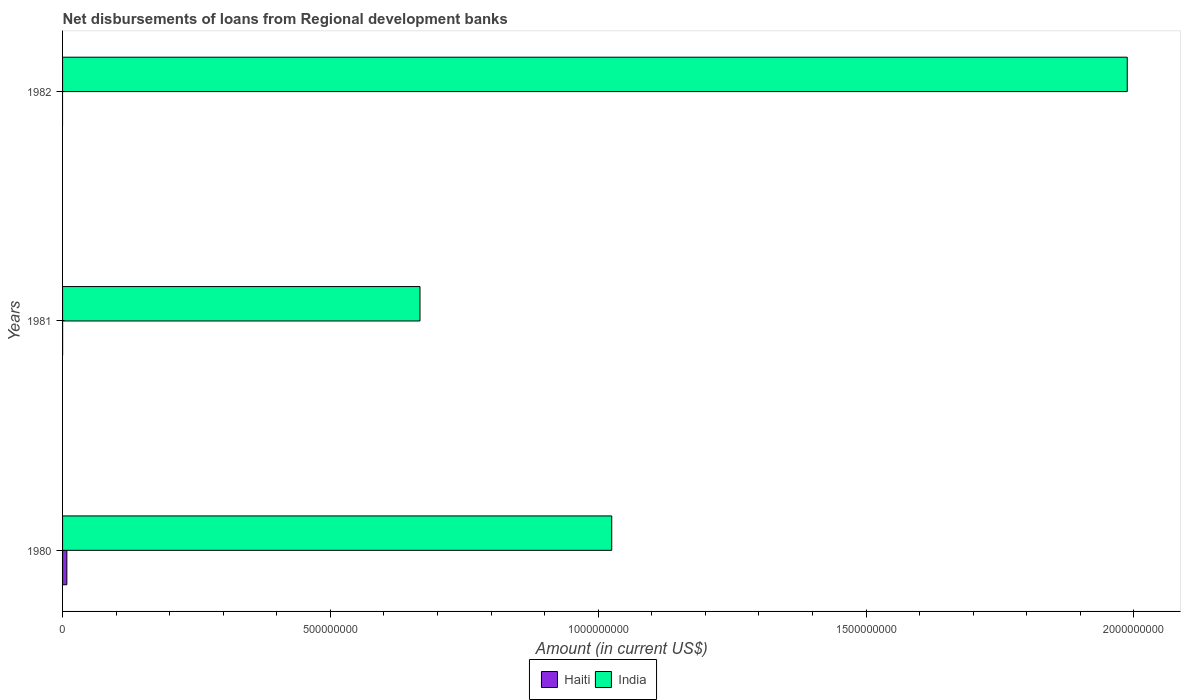How many bars are there on the 1st tick from the bottom?
Offer a terse response. 2. What is the label of the 3rd group of bars from the top?
Your answer should be very brief. 1980. What is the amount of disbursements of loans from regional development banks in Haiti in 1982?
Your answer should be very brief. 0. Across all years, what is the maximum amount of disbursements of loans from regional development banks in Haiti?
Your response must be concise. 7.99e+06. Across all years, what is the minimum amount of disbursements of loans from regional development banks in India?
Provide a succinct answer. 6.67e+08. What is the total amount of disbursements of loans from regional development banks in India in the graph?
Your response must be concise. 3.68e+09. What is the difference between the amount of disbursements of loans from regional development banks in India in 1981 and that in 1982?
Offer a terse response. -1.32e+09. What is the difference between the amount of disbursements of loans from regional development banks in Haiti in 1981 and the amount of disbursements of loans from regional development banks in India in 1982?
Provide a short and direct response. -1.99e+09. What is the average amount of disbursements of loans from regional development banks in Haiti per year?
Give a very brief answer. 2.69e+06. In the year 1980, what is the difference between the amount of disbursements of loans from regional development banks in India and amount of disbursements of loans from regional development banks in Haiti?
Ensure brevity in your answer.  1.02e+09. What is the ratio of the amount of disbursements of loans from regional development banks in India in 1981 to that in 1982?
Make the answer very short. 0.34. What is the difference between the highest and the lowest amount of disbursements of loans from regional development banks in Haiti?
Offer a very short reply. 7.99e+06. Is the sum of the amount of disbursements of loans from regional development banks in India in 1981 and 1982 greater than the maximum amount of disbursements of loans from regional development banks in Haiti across all years?
Make the answer very short. Yes. How many years are there in the graph?
Your answer should be very brief. 3. Does the graph contain any zero values?
Your answer should be very brief. Yes. How many legend labels are there?
Provide a succinct answer. 2. How are the legend labels stacked?
Give a very brief answer. Horizontal. What is the title of the graph?
Your answer should be very brief. Net disbursements of loans from Regional development banks. What is the label or title of the X-axis?
Ensure brevity in your answer.  Amount (in current US$). What is the label or title of the Y-axis?
Make the answer very short. Years. What is the Amount (in current US$) of Haiti in 1980?
Keep it short and to the point. 7.99e+06. What is the Amount (in current US$) in India in 1980?
Give a very brief answer. 1.03e+09. What is the Amount (in current US$) of Haiti in 1981?
Your answer should be compact. 8.70e+04. What is the Amount (in current US$) of India in 1981?
Give a very brief answer. 6.67e+08. What is the Amount (in current US$) of India in 1982?
Provide a succinct answer. 1.99e+09. Across all years, what is the maximum Amount (in current US$) of Haiti?
Provide a short and direct response. 7.99e+06. Across all years, what is the maximum Amount (in current US$) in India?
Your response must be concise. 1.99e+09. Across all years, what is the minimum Amount (in current US$) in Haiti?
Your response must be concise. 0. Across all years, what is the minimum Amount (in current US$) of India?
Your answer should be compact. 6.67e+08. What is the total Amount (in current US$) of Haiti in the graph?
Give a very brief answer. 8.07e+06. What is the total Amount (in current US$) in India in the graph?
Give a very brief answer. 3.68e+09. What is the difference between the Amount (in current US$) in Haiti in 1980 and that in 1981?
Ensure brevity in your answer.  7.90e+06. What is the difference between the Amount (in current US$) of India in 1980 and that in 1981?
Your answer should be compact. 3.58e+08. What is the difference between the Amount (in current US$) of India in 1980 and that in 1982?
Offer a terse response. -9.62e+08. What is the difference between the Amount (in current US$) in India in 1981 and that in 1982?
Your answer should be very brief. -1.32e+09. What is the difference between the Amount (in current US$) of Haiti in 1980 and the Amount (in current US$) of India in 1981?
Provide a short and direct response. -6.59e+08. What is the difference between the Amount (in current US$) of Haiti in 1980 and the Amount (in current US$) of India in 1982?
Your response must be concise. -1.98e+09. What is the difference between the Amount (in current US$) of Haiti in 1981 and the Amount (in current US$) of India in 1982?
Your answer should be compact. -1.99e+09. What is the average Amount (in current US$) in Haiti per year?
Ensure brevity in your answer.  2.69e+06. What is the average Amount (in current US$) of India per year?
Provide a short and direct response. 1.23e+09. In the year 1980, what is the difference between the Amount (in current US$) of Haiti and Amount (in current US$) of India?
Provide a succinct answer. -1.02e+09. In the year 1981, what is the difference between the Amount (in current US$) of Haiti and Amount (in current US$) of India?
Offer a very short reply. -6.67e+08. What is the ratio of the Amount (in current US$) of Haiti in 1980 to that in 1981?
Keep it short and to the point. 91.8. What is the ratio of the Amount (in current US$) in India in 1980 to that in 1981?
Your answer should be very brief. 1.54. What is the ratio of the Amount (in current US$) in India in 1980 to that in 1982?
Provide a succinct answer. 0.52. What is the ratio of the Amount (in current US$) in India in 1981 to that in 1982?
Your answer should be compact. 0.34. What is the difference between the highest and the second highest Amount (in current US$) of India?
Your response must be concise. 9.62e+08. What is the difference between the highest and the lowest Amount (in current US$) of Haiti?
Provide a short and direct response. 7.99e+06. What is the difference between the highest and the lowest Amount (in current US$) in India?
Offer a terse response. 1.32e+09. 